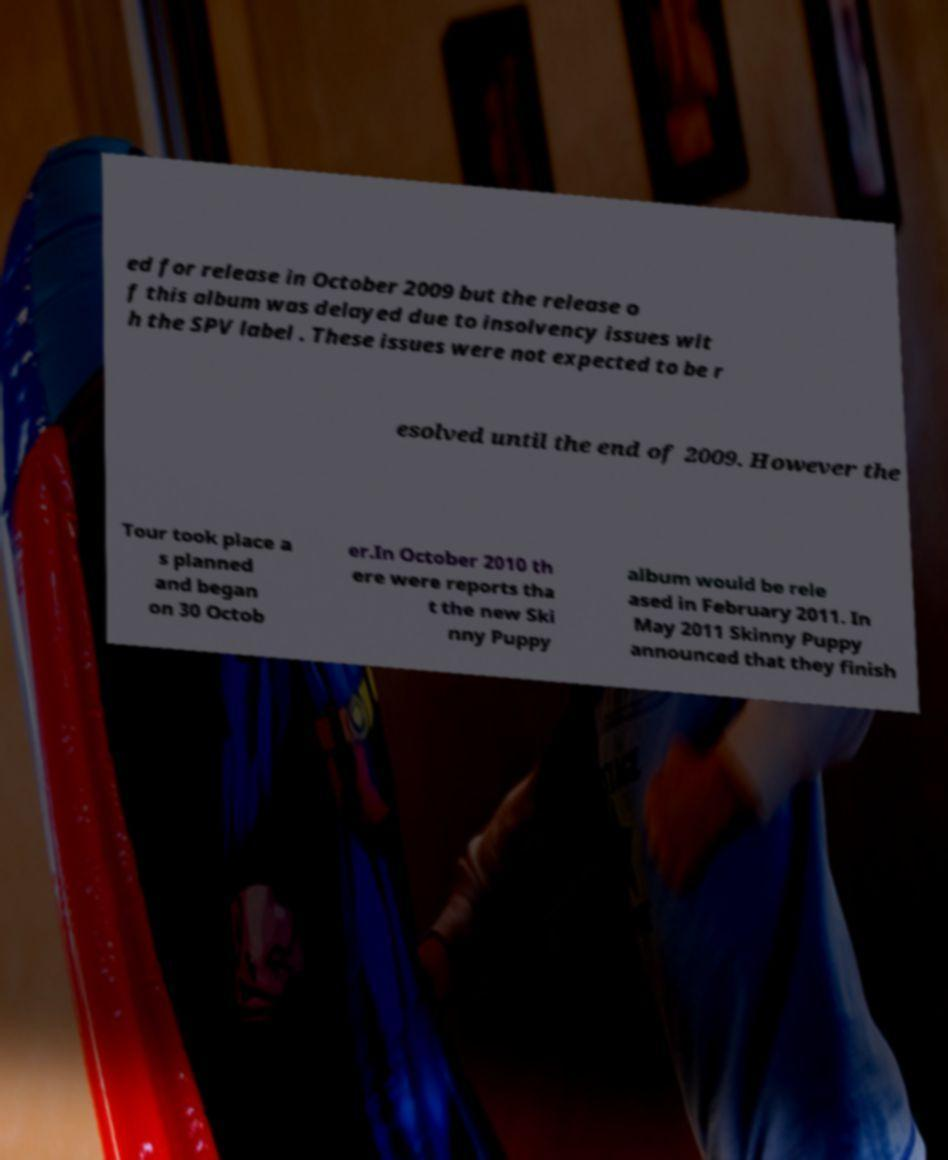There's text embedded in this image that I need extracted. Can you transcribe it verbatim? ed for release in October 2009 but the release o f this album was delayed due to insolvency issues wit h the SPV label . These issues were not expected to be r esolved until the end of 2009. However the Tour took place a s planned and began on 30 Octob er.In October 2010 th ere were reports tha t the new Ski nny Puppy album would be rele ased in February 2011. In May 2011 Skinny Puppy announced that they finish 